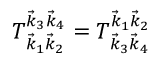Convert formula to latex. <formula><loc_0><loc_0><loc_500><loc_500>T _ { \vec { k } _ { 1 } \vec { k } _ { 2 } } ^ { \vec { k } _ { 3 } \vec { k } _ { 4 } } = T _ { \vec { k } _ { 3 } \vec { k } _ { 4 } } ^ { \vec { k } _ { 1 } \vec { k } _ { 2 } }</formula> 